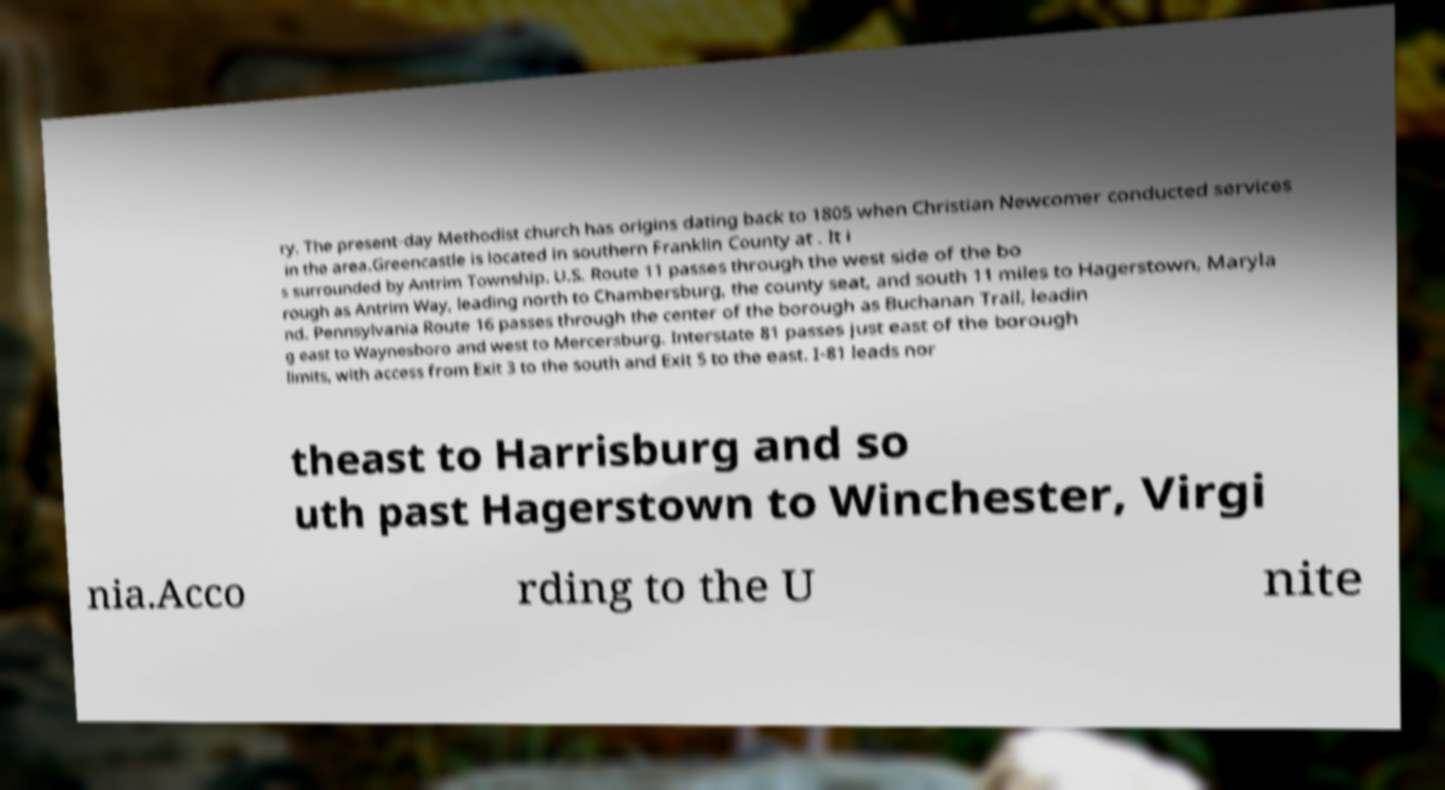Please read and relay the text visible in this image. What does it say? ry. The present-day Methodist church has origins dating back to 1805 when Christian Newcomer conducted services in the area.Greencastle is located in southern Franklin County at . It i s surrounded by Antrim Township. U.S. Route 11 passes through the west side of the bo rough as Antrim Way, leading north to Chambersburg, the county seat, and south 11 miles to Hagerstown, Maryla nd. Pennsylvania Route 16 passes through the center of the borough as Buchanan Trail, leadin g east to Waynesboro and west to Mercersburg. Interstate 81 passes just east of the borough limits, with access from Exit 3 to the south and Exit 5 to the east. I-81 leads nor theast to Harrisburg and so uth past Hagerstown to Winchester, Virgi nia.Acco rding to the U nite 